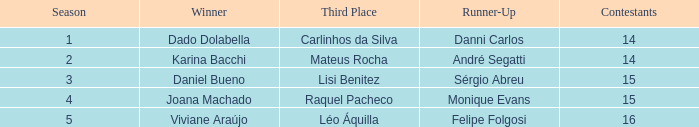How many contestants were there when the runner-up was Sérgio Abreu?  15.0. 